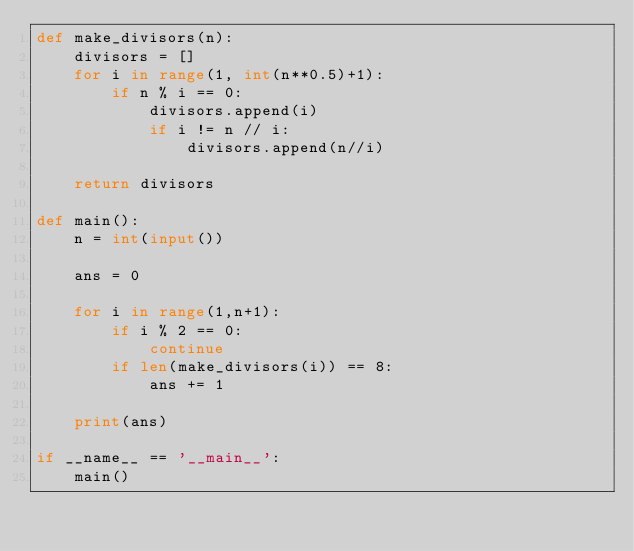Convert code to text. <code><loc_0><loc_0><loc_500><loc_500><_Python_>def make_divisors(n):
    divisors = []
    for i in range(1, int(n**0.5)+1):
        if n % i == 0:
            divisors.append(i)
            if i != n // i:
                divisors.append(n//i)

    return divisors

def main():
    n = int(input())

    ans = 0

    for i in range(1,n+1):
        if i % 2 == 0:
            continue
        if len(make_divisors(i)) == 8:
            ans += 1
        
    print(ans)

if __name__ == '__main__':
    main()</code> 